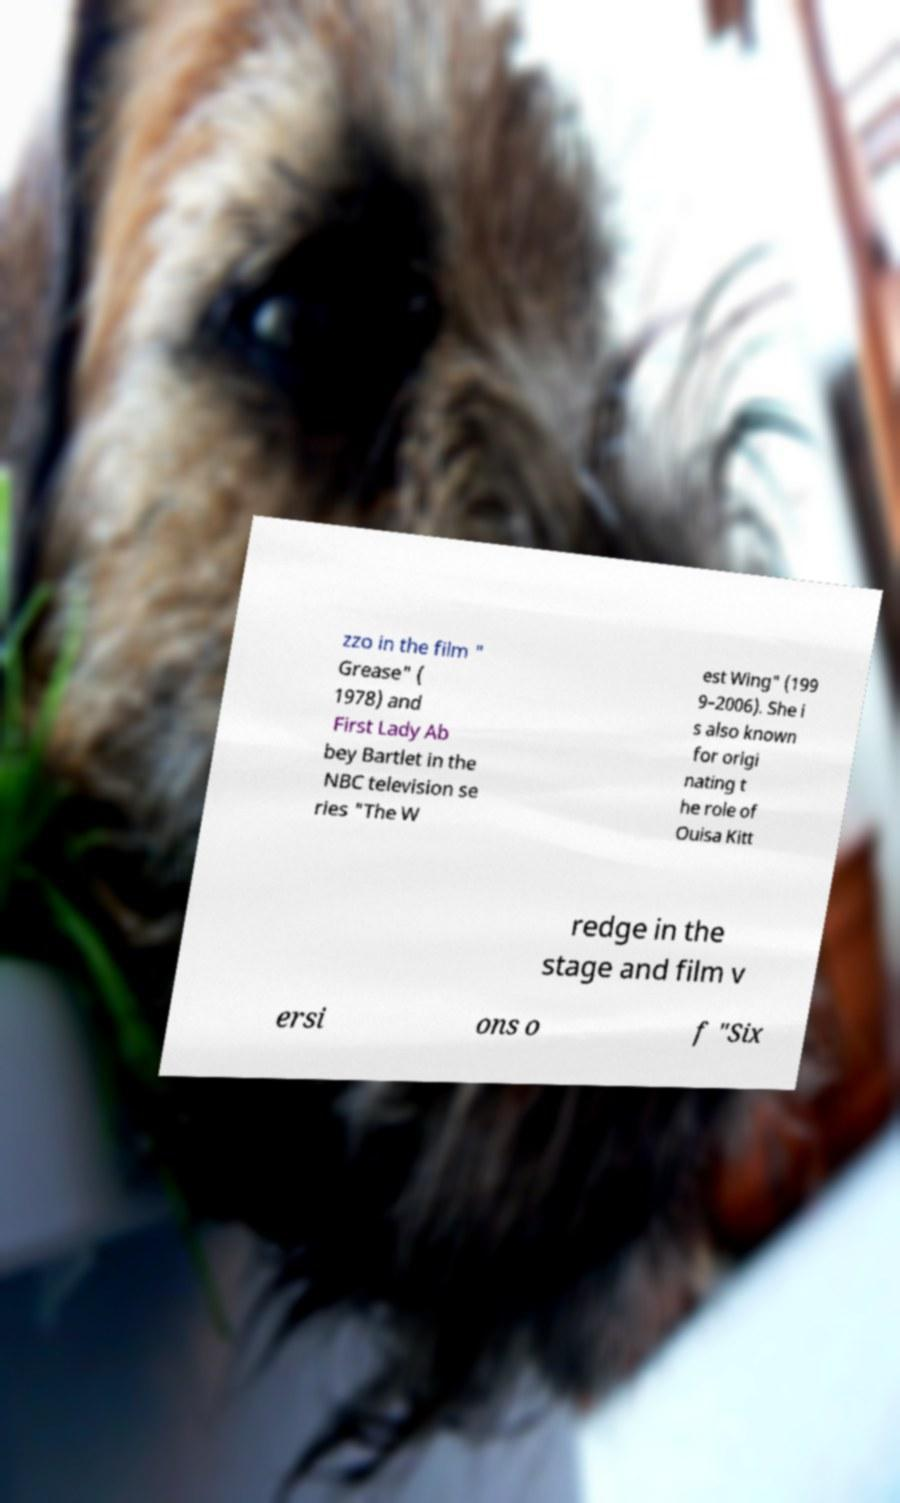Please identify and transcribe the text found in this image. zzo in the film " Grease" ( 1978) and First Lady Ab bey Bartlet in the NBC television se ries "The W est Wing" (199 9–2006). She i s also known for origi nating t he role of Ouisa Kitt redge in the stage and film v ersi ons o f "Six 